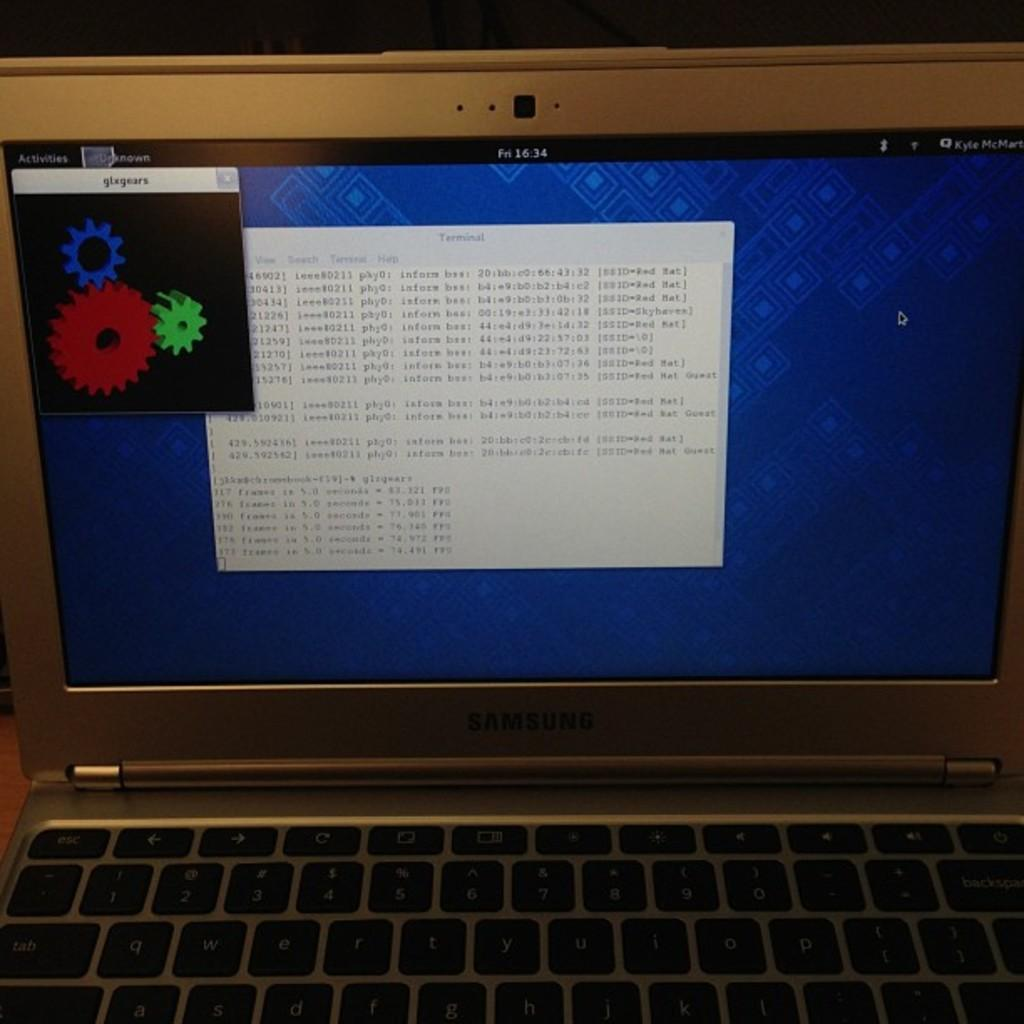<image>
Share a concise interpretation of the image provided. A laptop screen has fn1634 on the black border of the display. 